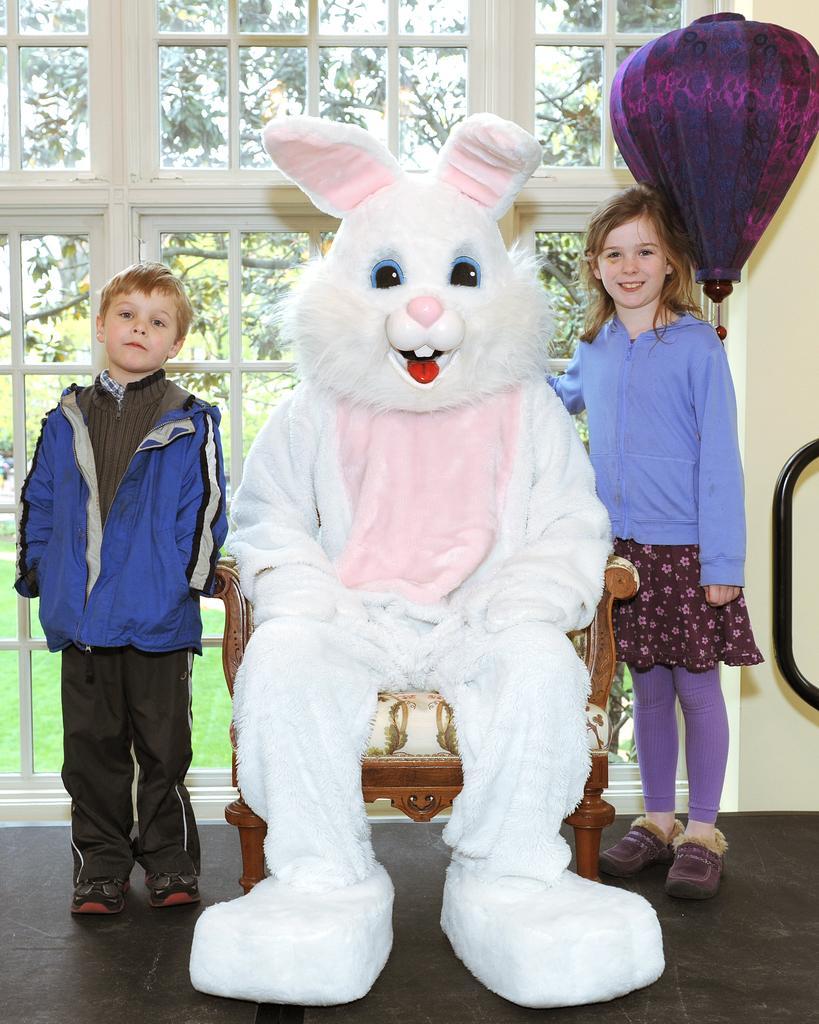Could you give a brief overview of what you see in this image? In this image there is a person wearing a costume of a rabbit. On the left and right side of the chair there are children's, behind them there is a window and an object hanging on the wall. In the background there are trees. 